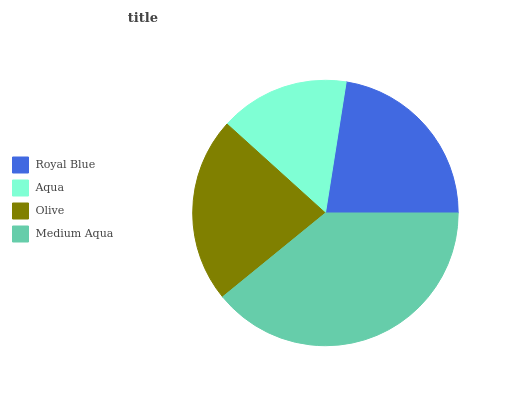Is Aqua the minimum?
Answer yes or no. Yes. Is Medium Aqua the maximum?
Answer yes or no. Yes. Is Olive the minimum?
Answer yes or no. No. Is Olive the maximum?
Answer yes or no. No. Is Olive greater than Aqua?
Answer yes or no. Yes. Is Aqua less than Olive?
Answer yes or no. Yes. Is Aqua greater than Olive?
Answer yes or no. No. Is Olive less than Aqua?
Answer yes or no. No. Is Olive the high median?
Answer yes or no. Yes. Is Royal Blue the low median?
Answer yes or no. Yes. Is Royal Blue the high median?
Answer yes or no. No. Is Medium Aqua the low median?
Answer yes or no. No. 